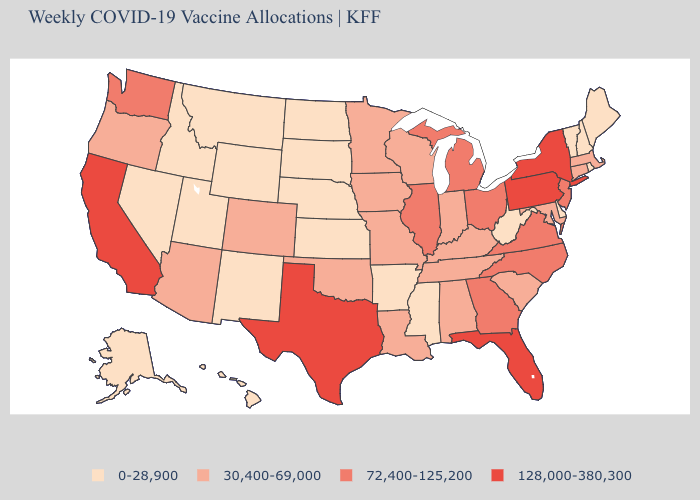Among the states that border Louisiana , does Arkansas have the highest value?
Give a very brief answer. No. What is the lowest value in states that border West Virginia?
Short answer required. 30,400-69,000. How many symbols are there in the legend?
Quick response, please. 4. Among the states that border Maryland , which have the highest value?
Answer briefly. Pennsylvania. Does Nebraska have the same value as Connecticut?
Quick response, please. No. Does the map have missing data?
Keep it brief. No. What is the value of Michigan?
Quick response, please. 72,400-125,200. Does New York have the lowest value in the Northeast?
Concise answer only. No. What is the lowest value in the USA?
Write a very short answer. 0-28,900. Name the states that have a value in the range 72,400-125,200?
Short answer required. Georgia, Illinois, Michigan, New Jersey, North Carolina, Ohio, Virginia, Washington. Name the states that have a value in the range 30,400-69,000?
Quick response, please. Alabama, Arizona, Colorado, Connecticut, Indiana, Iowa, Kentucky, Louisiana, Maryland, Massachusetts, Minnesota, Missouri, Oklahoma, Oregon, South Carolina, Tennessee, Wisconsin. What is the highest value in the West ?
Be succinct. 128,000-380,300. Name the states that have a value in the range 30,400-69,000?
Answer briefly. Alabama, Arizona, Colorado, Connecticut, Indiana, Iowa, Kentucky, Louisiana, Maryland, Massachusetts, Minnesota, Missouri, Oklahoma, Oregon, South Carolina, Tennessee, Wisconsin. Does Oregon have the lowest value in the USA?
Concise answer only. No. 